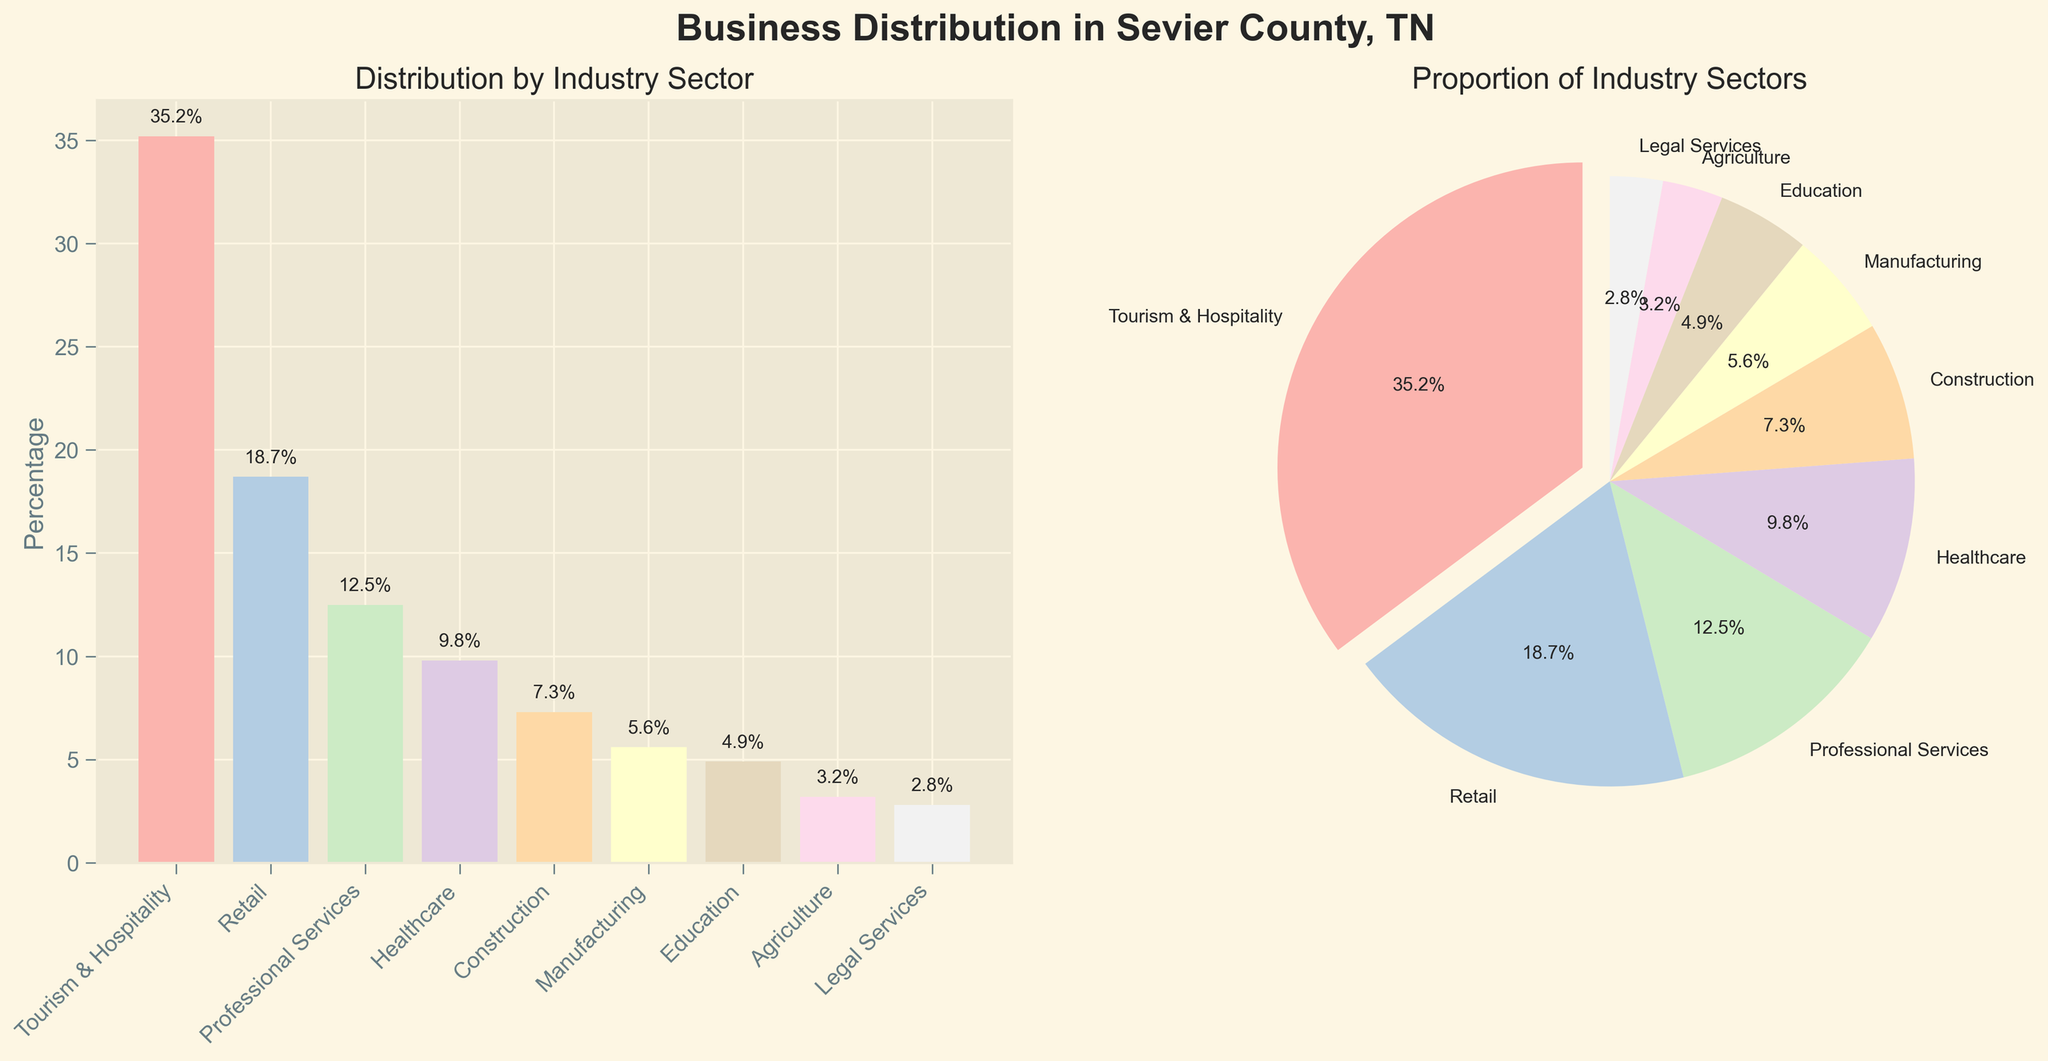What's the title of the figure? The title is located at the top of the figure. It reads "Business Distribution in Sevier County, TN".
Answer: Business Distribution in Sevier County, TN Which industry sector holds the highest percentage in the bar plot? The bar corresponding to Tourism & Hospitality is the highest, showing a percentage of 35.2%.
Answer: Tourism & Hospitality How much higher is the percentage of Tourism & Hospitality compared to Retail? The bar plot indicates Tourism & Hospitality is at 35.2%, and Retail is at 18.7%. The difference is 35.2% - 18.7% = 16.5%.
Answer: 16.5% What is the total percentage for the top 3 industry sectors? The top 3 sectors are Tourism & Hospitality (35.2%), Retail (18.7%), and Professional Services (12.5%). Sum these values: 35.2 + 18.7 + 12.5 = 66.4%.
Answer: 66.4% What does the pie chart show when comparing the percentages? The pie chart visually represents the proportions of each industry sector. The largest sector, Tourism & Hospitality, is exploded to highlight its dominance.
Answer: Proportion of Industry Sectors Which specific visual element highlights the largest industry sector in the pie chart? The largest sector (Tourism & Hospitality) is indicated by the explosion effect in the pie chart.
Answer: Explosion effect In the bar plot, which industry sector has the smallest percentage? The smallest bar in the plot belongs to Legal Services, showing a percentage of 2.8%.
Answer: Legal Services What is the total percentage of all represented industry sectors? Summing all listed percentages: 35.2 + 18.7 + 12.5 + 9.8 + 7.3 + 5.6 + 4.9 + 3.2 + 2.8 = 100%.
Answer: 100% Which industry sectors together make up more than 50%? The combined total of Tourism & Hospitality (35.2%), Retail (18.7%), and Professional Services (12.5%) is 66.4%, which is more than 50%.
Answer: Tourism & Hospitality, Retail, Professional Services 